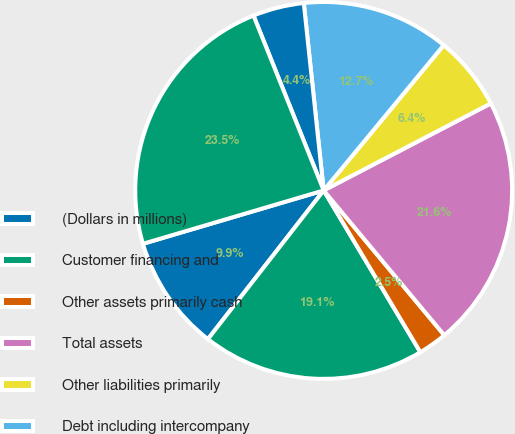Convert chart to OTSL. <chart><loc_0><loc_0><loc_500><loc_500><pie_chart><fcel>(Dollars in millions)<fcel>Customer financing and<fcel>Other assets primarily cash<fcel>Total assets<fcel>Other liabilities primarily<fcel>Debt including intercompany<fcel>Equity<fcel>Total liabilities and equity<nl><fcel>9.9%<fcel>19.1%<fcel>2.48%<fcel>21.58%<fcel>6.37%<fcel>12.67%<fcel>4.39%<fcel>23.49%<nl></chart> 